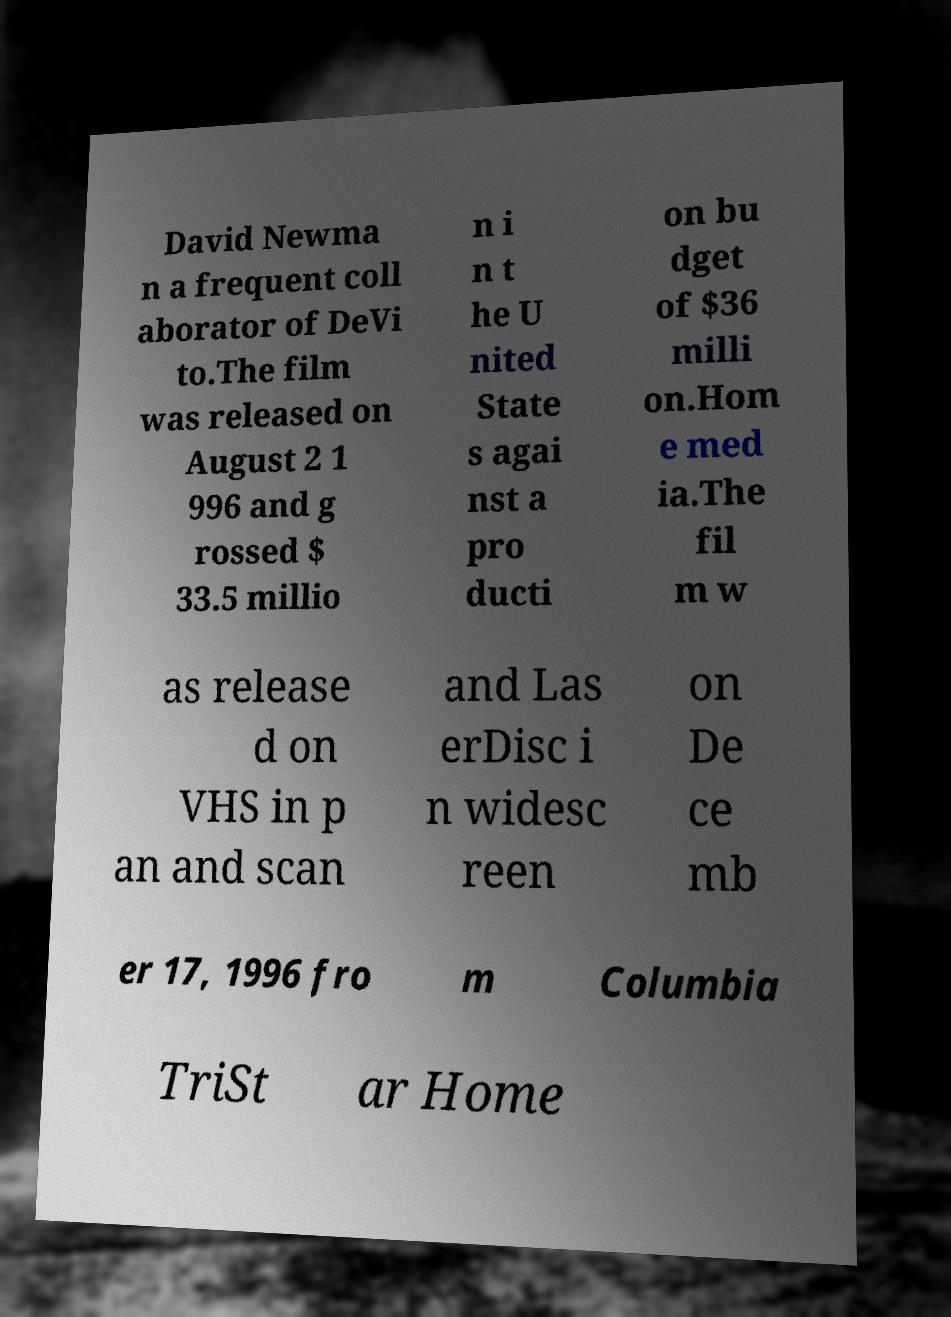What messages or text are displayed in this image? I need them in a readable, typed format. David Newma n a frequent coll aborator of DeVi to.The film was released on August 2 1 996 and g rossed $ 33.5 millio n i n t he U nited State s agai nst a pro ducti on bu dget of $36 milli on.Hom e med ia.The fil m w as release d on VHS in p an and scan and Las erDisc i n widesc reen on De ce mb er 17, 1996 fro m Columbia TriSt ar Home 